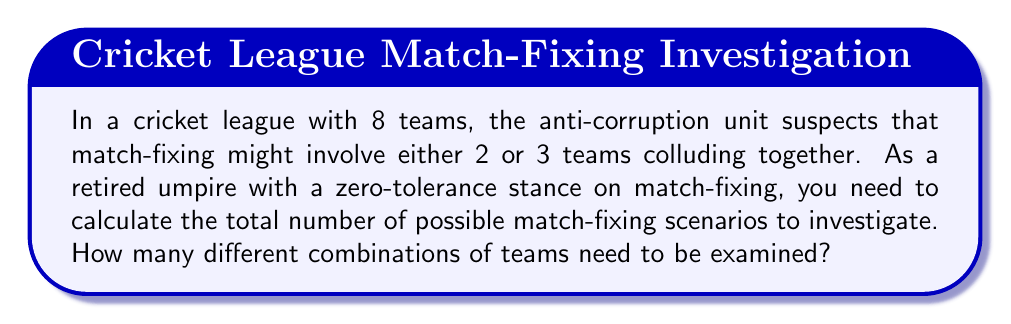Solve this math problem. Let's approach this problem step-by-step:

1) We need to calculate the number of combinations for two scenarios:
   a) 2 teams colluding
   b) 3 teams colluding

2) For 2 teams colluding:
   This is a combination problem where we choose 2 teams from 8.
   We can represent this as $\binom{8}{2}$.
   
   $$\binom{8}{2} = \frac{8!}{2!(8-2)!} = \frac{8!}{2!6!} = \frac{8 \cdot 7}{2 \cdot 1} = 28$$

3) For 3 teams colluding:
   This is a combination problem where we choose 3 teams from 8.
   We can represent this as $\binom{8}{3}$.
   
   $$\binom{8}{3} = \frac{8!}{3!(8-3)!} = \frac{8!}{3!5!} = \frac{8 \cdot 7 \cdot 6}{3 \cdot 2 \cdot 1} = 56$$

4) The total number of scenarios to investigate is the sum of these two combinations:

   Total scenarios = $\binom{8}{2} + \binom{8}{3} = 28 + 56 = 84$

Therefore, there are 84 different combinations of teams that need to be examined for potential match-fixing.
Answer: 84 scenarios 